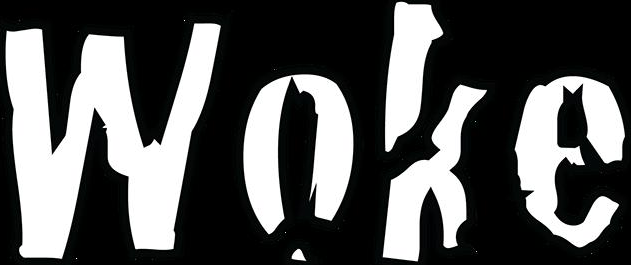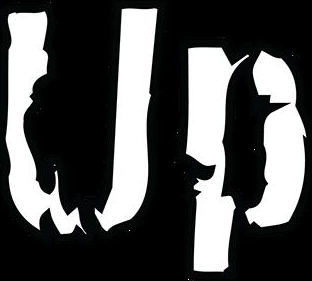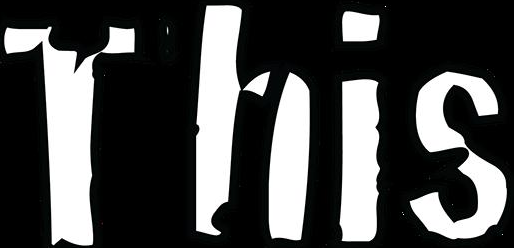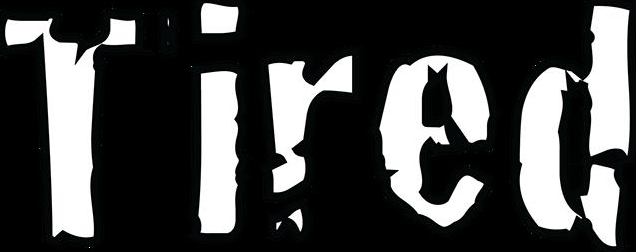What words can you see in these images in sequence, separated by a semicolon? Woke; Up; This; Tired 